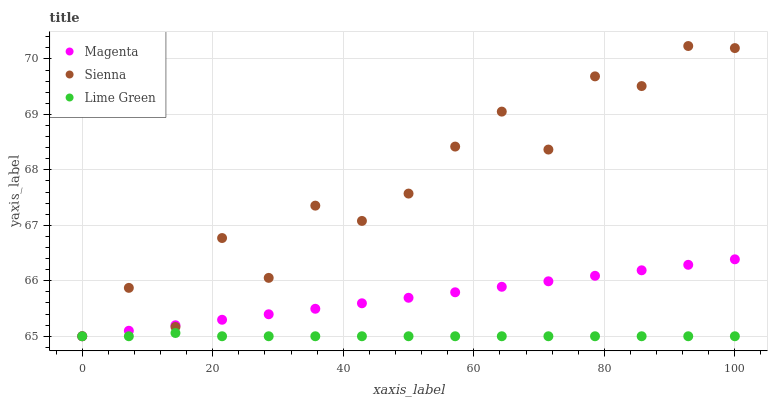Does Lime Green have the minimum area under the curve?
Answer yes or no. Yes. Does Sienna have the maximum area under the curve?
Answer yes or no. Yes. Does Magenta have the minimum area under the curve?
Answer yes or no. No. Does Magenta have the maximum area under the curve?
Answer yes or no. No. Is Magenta the smoothest?
Answer yes or no. Yes. Is Sienna the roughest?
Answer yes or no. Yes. Is Lime Green the smoothest?
Answer yes or no. No. Is Lime Green the roughest?
Answer yes or no. No. Does Sienna have the lowest value?
Answer yes or no. Yes. Does Sienna have the highest value?
Answer yes or no. Yes. Does Magenta have the highest value?
Answer yes or no. No. Does Lime Green intersect Sienna?
Answer yes or no. Yes. Is Lime Green less than Sienna?
Answer yes or no. No. Is Lime Green greater than Sienna?
Answer yes or no. No. 